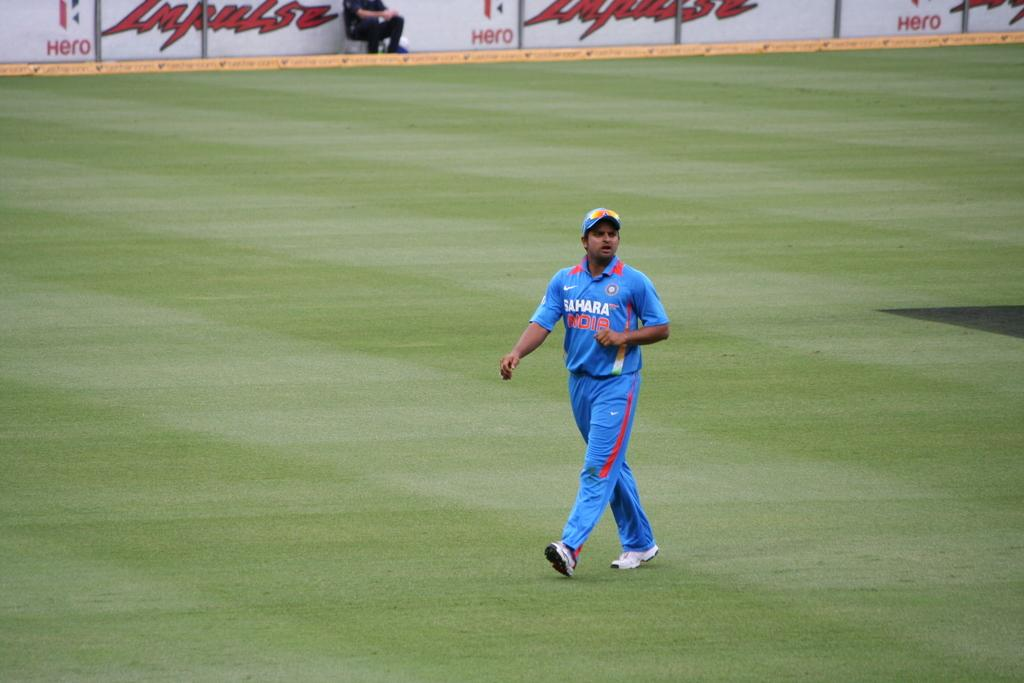Provide a one-sentence caption for the provided image. A man walks across an empty sports field wearing a Sahara India uniform. 